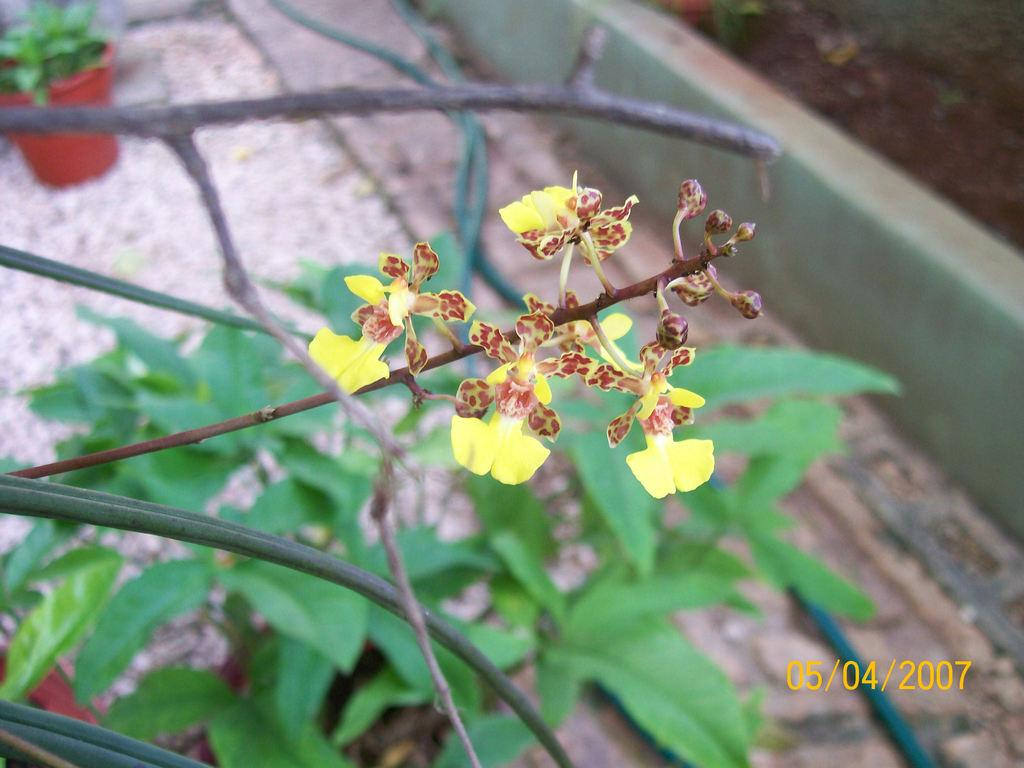What is the main subject of the image? The main subject of the image is flowers and plants. Can you describe the location of the flowers and plants in the image? The flowers and plants are in the center of the image. Are there any other plants visible in the image? Yes, there is a house plant visible in the background of the image. What type of amusement can be seen in the image? There is no amusement present in the image; it features flowers and plants. What disease is affecting the plants in the image? There is no indication of any disease affecting the plants in the image. 